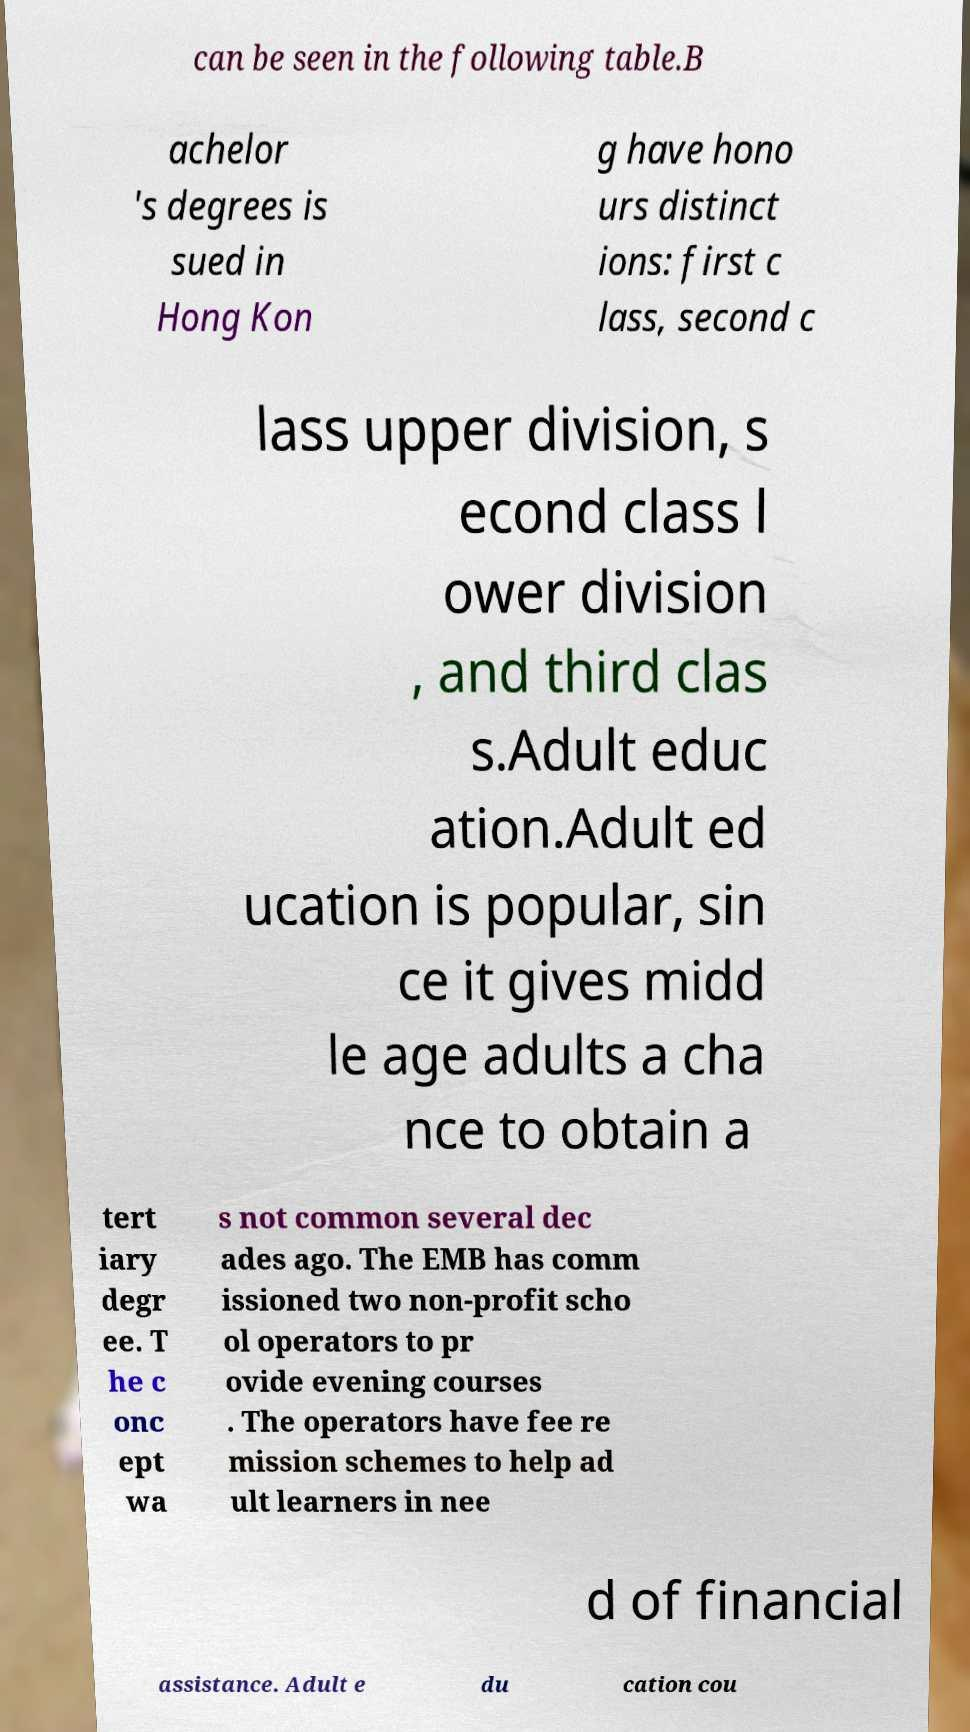Could you extract and type out the text from this image? can be seen in the following table.B achelor 's degrees is sued in Hong Kon g have hono urs distinct ions: first c lass, second c lass upper division, s econd class l ower division , and third clas s.Adult educ ation.Adult ed ucation is popular, sin ce it gives midd le age adults a cha nce to obtain a tert iary degr ee. T he c onc ept wa s not common several dec ades ago. The EMB has comm issioned two non-profit scho ol operators to pr ovide evening courses . The operators have fee re mission schemes to help ad ult learners in nee d of financial assistance. Adult e du cation cou 